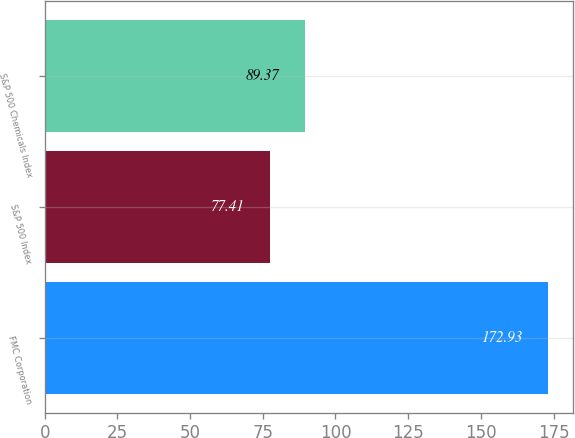Convert chart to OTSL. <chart><loc_0><loc_0><loc_500><loc_500><bar_chart><fcel>FMC Corporation<fcel>S&P 500 Index<fcel>S&P 500 Chemicals Index<nl><fcel>172.93<fcel>77.41<fcel>89.37<nl></chart> 